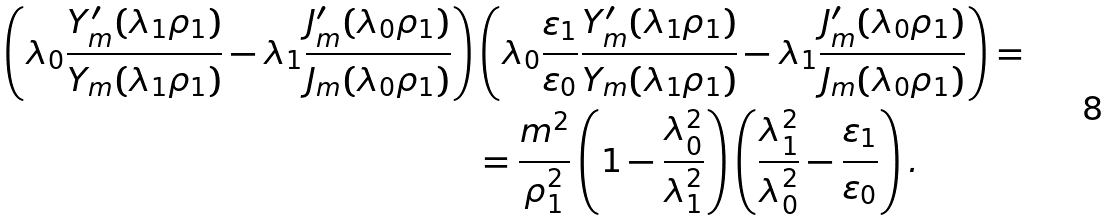<formula> <loc_0><loc_0><loc_500><loc_500>\left ( \lambda _ { 0 } \frac { Y ^ { \prime } _ { m } ( \lambda _ { 1 } \rho _ { 1 } ) } { Y _ { m } ( \lambda _ { 1 } \rho _ { 1 } ) } - \lambda _ { 1 } \frac { J ^ { \prime } _ { m } ( \lambda _ { 0 } \rho _ { 1 } ) } { J _ { m } ( \lambda _ { 0 } \rho _ { 1 } ) } \right ) & \left ( \lambda _ { 0 } \frac { \varepsilon _ { 1 } } { \varepsilon _ { 0 } } \frac { Y ^ { \prime } _ { m } ( \lambda _ { 1 } \rho _ { 1 } ) } { Y _ { m } ( \lambda _ { 1 } \rho _ { 1 } ) } - \lambda _ { 1 } \frac { J ^ { \prime } _ { m } ( \lambda _ { 0 } \rho _ { 1 } ) } { J _ { m } ( \lambda _ { 0 } \rho _ { 1 } ) } \right ) = \\ & = \frac { m ^ { 2 } } { \rho _ { 1 } ^ { 2 } } \left ( 1 - \frac { \lambda _ { 0 } ^ { 2 } } { \lambda _ { 1 } ^ { 2 } } \right ) \left ( \frac { \lambda _ { 1 } ^ { 2 } } { \lambda _ { 0 } ^ { 2 } } - \frac { \varepsilon _ { 1 } } { \varepsilon _ { 0 } } \right ) .</formula> 